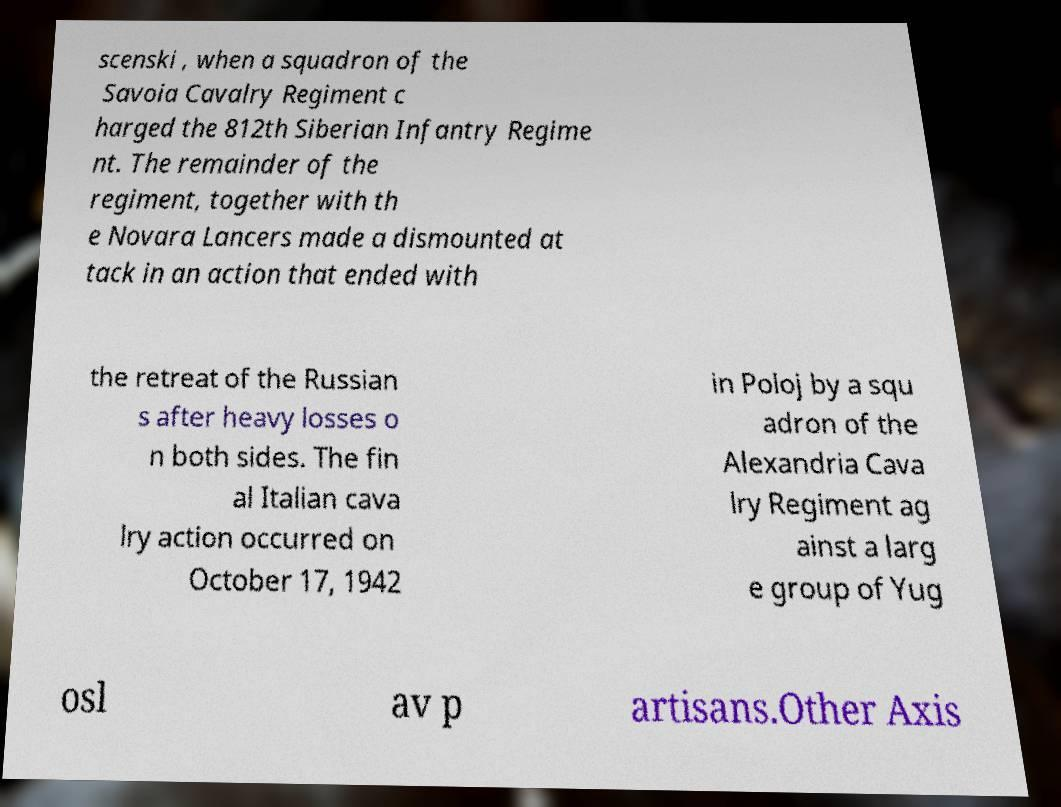I need the written content from this picture converted into text. Can you do that? scenski , when a squadron of the Savoia Cavalry Regiment c harged the 812th Siberian Infantry Regime nt. The remainder of the regiment, together with th e Novara Lancers made a dismounted at tack in an action that ended with the retreat of the Russian s after heavy losses o n both sides. The fin al Italian cava lry action occurred on October 17, 1942 in Poloj by a squ adron of the Alexandria Cava lry Regiment ag ainst a larg e group of Yug osl av p artisans.Other Axis 